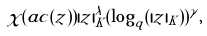<formula> <loc_0><loc_0><loc_500><loc_500>\chi ( a c ( z ) ) | z | _ { K } ^ { \lambda } ( \log _ { q } ( | z | _ { K } ) ) ^ { \gamma } ,</formula> 